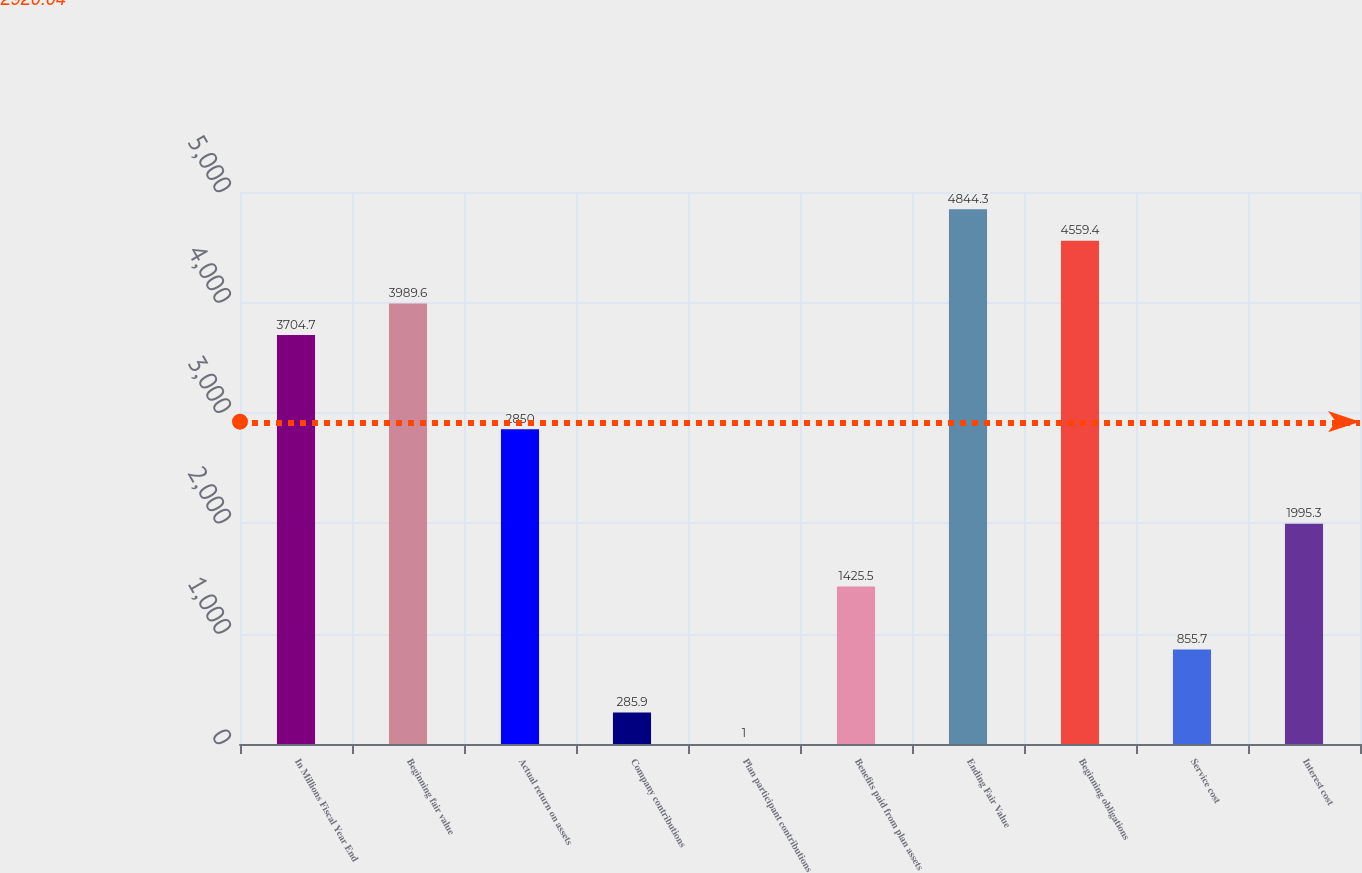Convert chart to OTSL. <chart><loc_0><loc_0><loc_500><loc_500><bar_chart><fcel>In Millions Fiscal Year End<fcel>Beginning fair value<fcel>Actual return on assets<fcel>Company contributions<fcel>Plan participant contributions<fcel>Benefits paid from plan assets<fcel>Ending Fair Value<fcel>Beginning obligations<fcel>Service cost<fcel>Interest cost<nl><fcel>3704.7<fcel>3989.6<fcel>2850<fcel>285.9<fcel>1<fcel>1425.5<fcel>4844.3<fcel>4559.4<fcel>855.7<fcel>1995.3<nl></chart> 